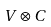Convert formula to latex. <formula><loc_0><loc_0><loc_500><loc_500>V \otimes C</formula> 